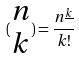<formula> <loc_0><loc_0><loc_500><loc_500>( \begin{matrix} n \\ k \end{matrix} ) = \frac { n ^ { \underline { k } } } { k ! }</formula> 